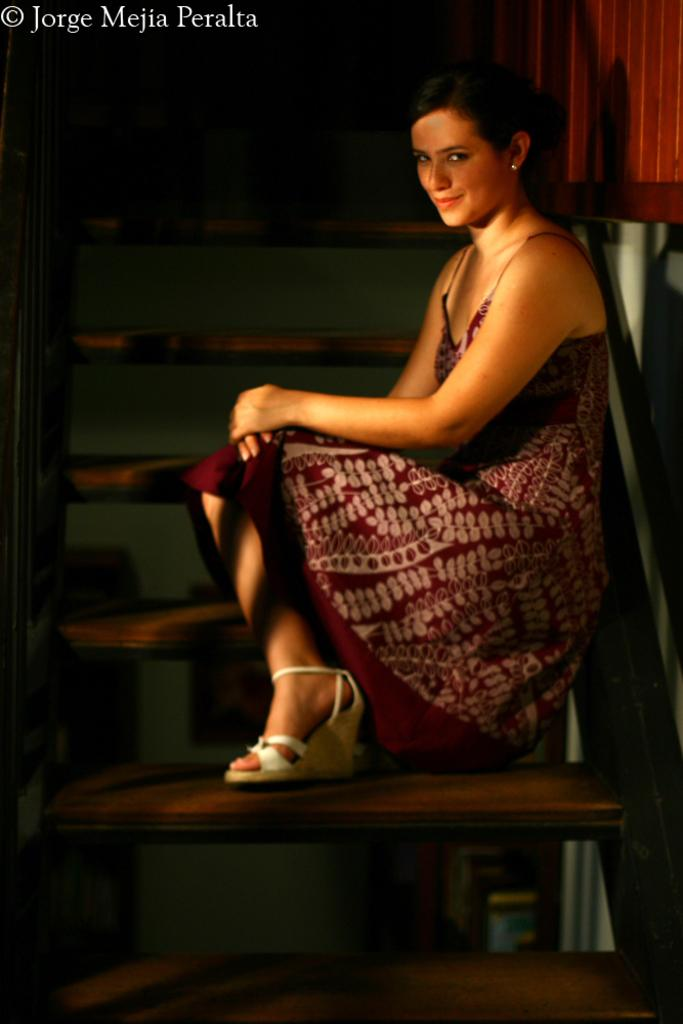Who is the main subject in the image? There is a woman in the image. What is the woman doing in the image? The woman is sitting on the stairs and giving a pose for the picture. What is the woman's facial expression in the image? The woman is smiling in the image. What can be observed about the lighting in the image? The background of the image is dark. Is there any text present in the image? Yes, there is some text in the top left-hand corner of the image. What is the woman's opinion on the balls in the image? There are no balls present in the image, so it is not possible to determine the woman's opinion on them. 